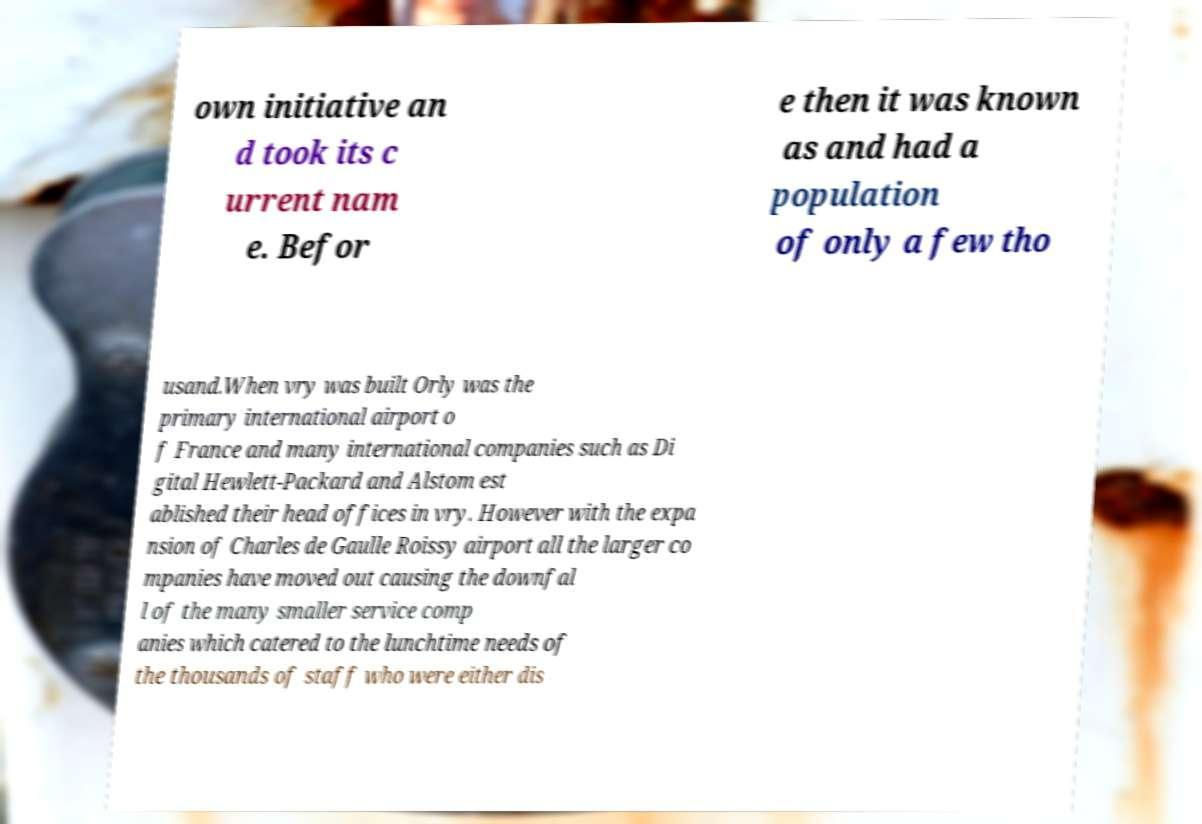Please read and relay the text visible in this image. What does it say? own initiative an d took its c urrent nam e. Befor e then it was known as and had a population of only a few tho usand.When vry was built Orly was the primary international airport o f France and many international companies such as Di gital Hewlett-Packard and Alstom est ablished their head offices in vry. However with the expa nsion of Charles de Gaulle Roissy airport all the larger co mpanies have moved out causing the downfal l of the many smaller service comp anies which catered to the lunchtime needs of the thousands of staff who were either dis 